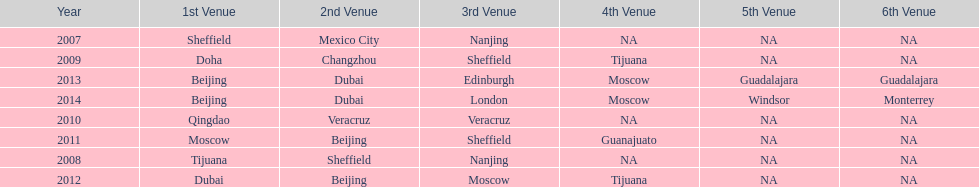Which two venue has no nations from 2007-2012 5th Venue, 6th Venue. 